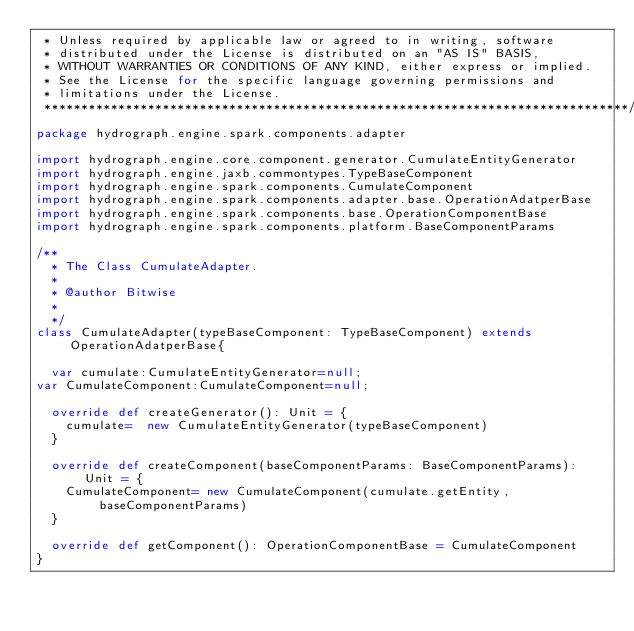<code> <loc_0><loc_0><loc_500><loc_500><_Scala_> * Unless required by applicable law or agreed to in writing, software
 * distributed under the License is distributed on an "AS IS" BASIS,
 * WITHOUT WARRANTIES OR CONDITIONS OF ANY KIND, either express or implied.
 * See the License for the specific language governing permissions and
 * limitations under the License.
 *******************************************************************************/
package hydrograph.engine.spark.components.adapter

import hydrograph.engine.core.component.generator.CumulateEntityGenerator
import hydrograph.engine.jaxb.commontypes.TypeBaseComponent
import hydrograph.engine.spark.components.CumulateComponent
import hydrograph.engine.spark.components.adapter.base.OperationAdatperBase
import hydrograph.engine.spark.components.base.OperationComponentBase
import hydrograph.engine.spark.components.platform.BaseComponentParams

/**
  * The Class CumulateAdapter.
  *
  * @author Bitwise
  *
  */
class CumulateAdapter(typeBaseComponent: TypeBaseComponent) extends OperationAdatperBase{

  var cumulate:CumulateEntityGenerator=null;
var CumulateComponent:CumulateComponent=null;

  override def createGenerator(): Unit = {
    cumulate=  new CumulateEntityGenerator(typeBaseComponent)
  }

  override def createComponent(baseComponentParams: BaseComponentParams): Unit = {
    CumulateComponent= new CumulateComponent(cumulate.getEntity,baseComponentParams)
  }

  override def getComponent(): OperationComponentBase = CumulateComponent
}
</code> 